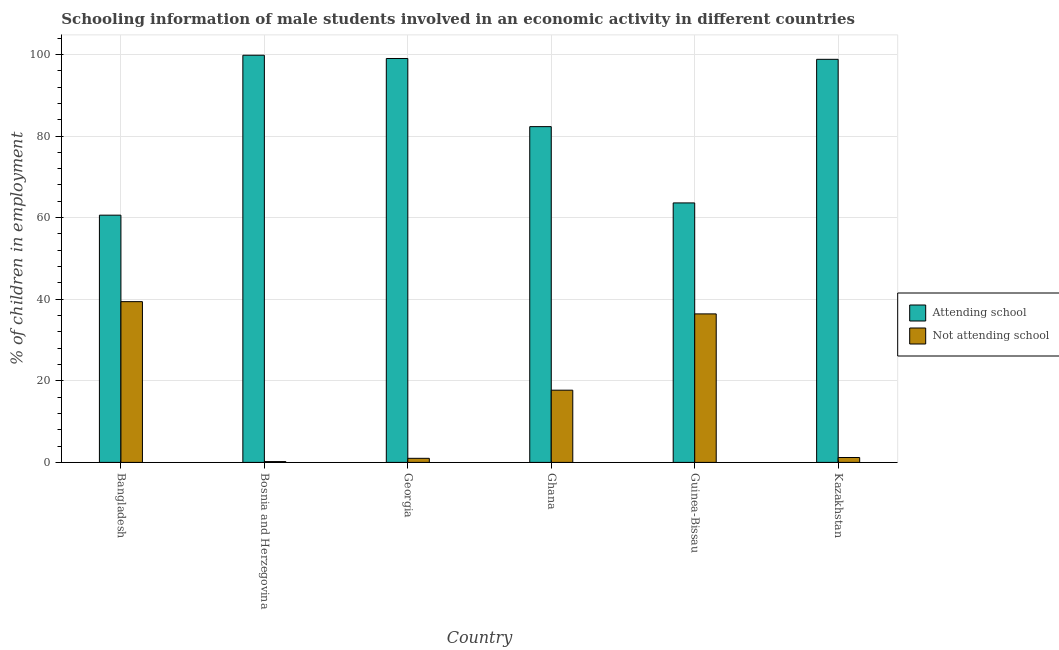Are the number of bars per tick equal to the number of legend labels?
Provide a short and direct response. Yes. How many bars are there on the 5th tick from the right?
Make the answer very short. 2. What is the label of the 3rd group of bars from the left?
Your response must be concise. Georgia. In how many cases, is the number of bars for a given country not equal to the number of legend labels?
Your response must be concise. 0. What is the percentage of employed males who are not attending school in Bosnia and Herzegovina?
Provide a short and direct response. 0.2. Across all countries, what is the maximum percentage of employed males who are not attending school?
Your answer should be very brief. 39.4. In which country was the percentage of employed males who are not attending school maximum?
Your answer should be very brief. Bangladesh. In which country was the percentage of employed males who are not attending school minimum?
Provide a short and direct response. Bosnia and Herzegovina. What is the total percentage of employed males who are not attending school in the graph?
Offer a very short reply. 95.9. What is the difference between the percentage of employed males who are not attending school in Ghana and that in Kazakhstan?
Make the answer very short. 16.5. What is the difference between the percentage of employed males who are not attending school in Georgia and the percentage of employed males who are attending school in Bosnia and Herzegovina?
Your answer should be compact. -98.8. What is the average percentage of employed males who are attending school per country?
Offer a very short reply. 84.02. What is the difference between the percentage of employed males who are not attending school and percentage of employed males who are attending school in Bosnia and Herzegovina?
Your answer should be very brief. -99.6. In how many countries, is the percentage of employed males who are not attending school greater than 84 %?
Provide a short and direct response. 0. What is the ratio of the percentage of employed males who are attending school in Georgia to that in Ghana?
Your response must be concise. 1.2. What is the difference between the highest and the lowest percentage of employed males who are attending school?
Make the answer very short. 39.2. In how many countries, is the percentage of employed males who are not attending school greater than the average percentage of employed males who are not attending school taken over all countries?
Keep it short and to the point. 3. Is the sum of the percentage of employed males who are attending school in Guinea-Bissau and Kazakhstan greater than the maximum percentage of employed males who are not attending school across all countries?
Your response must be concise. Yes. What does the 1st bar from the left in Bangladesh represents?
Your answer should be very brief. Attending school. What does the 1st bar from the right in Guinea-Bissau represents?
Offer a very short reply. Not attending school. How many bars are there?
Your response must be concise. 12. Does the graph contain grids?
Provide a short and direct response. Yes. How many legend labels are there?
Your answer should be very brief. 2. How are the legend labels stacked?
Your answer should be compact. Vertical. What is the title of the graph?
Make the answer very short. Schooling information of male students involved in an economic activity in different countries. What is the label or title of the Y-axis?
Offer a very short reply. % of children in employment. What is the % of children in employment of Attending school in Bangladesh?
Your response must be concise. 60.6. What is the % of children in employment in Not attending school in Bangladesh?
Your response must be concise. 39.4. What is the % of children in employment in Attending school in Bosnia and Herzegovina?
Your answer should be compact. 99.8. What is the % of children in employment in Not attending school in Georgia?
Offer a terse response. 1. What is the % of children in employment in Attending school in Ghana?
Provide a short and direct response. 82.3. What is the % of children in employment in Not attending school in Ghana?
Your response must be concise. 17.7. What is the % of children in employment of Attending school in Guinea-Bissau?
Make the answer very short. 63.6. What is the % of children in employment of Not attending school in Guinea-Bissau?
Your response must be concise. 36.4. What is the % of children in employment of Attending school in Kazakhstan?
Offer a very short reply. 98.8. Across all countries, what is the maximum % of children in employment of Attending school?
Make the answer very short. 99.8. Across all countries, what is the maximum % of children in employment of Not attending school?
Your answer should be compact. 39.4. Across all countries, what is the minimum % of children in employment in Attending school?
Your answer should be very brief. 60.6. What is the total % of children in employment of Attending school in the graph?
Ensure brevity in your answer.  504.1. What is the total % of children in employment of Not attending school in the graph?
Make the answer very short. 95.9. What is the difference between the % of children in employment in Attending school in Bangladesh and that in Bosnia and Herzegovina?
Your answer should be compact. -39.2. What is the difference between the % of children in employment of Not attending school in Bangladesh and that in Bosnia and Herzegovina?
Make the answer very short. 39.2. What is the difference between the % of children in employment in Attending school in Bangladesh and that in Georgia?
Make the answer very short. -38.4. What is the difference between the % of children in employment of Not attending school in Bangladesh and that in Georgia?
Ensure brevity in your answer.  38.4. What is the difference between the % of children in employment in Attending school in Bangladesh and that in Ghana?
Provide a succinct answer. -21.7. What is the difference between the % of children in employment in Not attending school in Bangladesh and that in Ghana?
Provide a succinct answer. 21.7. What is the difference between the % of children in employment in Not attending school in Bangladesh and that in Guinea-Bissau?
Provide a short and direct response. 3. What is the difference between the % of children in employment in Attending school in Bangladesh and that in Kazakhstan?
Offer a terse response. -38.2. What is the difference between the % of children in employment in Not attending school in Bangladesh and that in Kazakhstan?
Give a very brief answer. 38.2. What is the difference between the % of children in employment in Attending school in Bosnia and Herzegovina and that in Georgia?
Your answer should be very brief. 0.8. What is the difference between the % of children in employment in Not attending school in Bosnia and Herzegovina and that in Georgia?
Your answer should be very brief. -0.8. What is the difference between the % of children in employment in Not attending school in Bosnia and Herzegovina and that in Ghana?
Offer a terse response. -17.5. What is the difference between the % of children in employment in Attending school in Bosnia and Herzegovina and that in Guinea-Bissau?
Ensure brevity in your answer.  36.2. What is the difference between the % of children in employment in Not attending school in Bosnia and Herzegovina and that in Guinea-Bissau?
Your answer should be very brief. -36.2. What is the difference between the % of children in employment in Not attending school in Bosnia and Herzegovina and that in Kazakhstan?
Your response must be concise. -1. What is the difference between the % of children in employment in Attending school in Georgia and that in Ghana?
Your answer should be very brief. 16.7. What is the difference between the % of children in employment in Not attending school in Georgia and that in Ghana?
Offer a terse response. -16.7. What is the difference between the % of children in employment of Attending school in Georgia and that in Guinea-Bissau?
Offer a terse response. 35.4. What is the difference between the % of children in employment in Not attending school in Georgia and that in Guinea-Bissau?
Offer a terse response. -35.4. What is the difference between the % of children in employment of Not attending school in Georgia and that in Kazakhstan?
Your answer should be compact. -0.2. What is the difference between the % of children in employment in Not attending school in Ghana and that in Guinea-Bissau?
Your answer should be very brief. -18.7. What is the difference between the % of children in employment in Attending school in Ghana and that in Kazakhstan?
Provide a short and direct response. -16.5. What is the difference between the % of children in employment in Attending school in Guinea-Bissau and that in Kazakhstan?
Keep it short and to the point. -35.2. What is the difference between the % of children in employment in Not attending school in Guinea-Bissau and that in Kazakhstan?
Your answer should be compact. 35.2. What is the difference between the % of children in employment in Attending school in Bangladesh and the % of children in employment in Not attending school in Bosnia and Herzegovina?
Ensure brevity in your answer.  60.4. What is the difference between the % of children in employment in Attending school in Bangladesh and the % of children in employment in Not attending school in Georgia?
Your response must be concise. 59.6. What is the difference between the % of children in employment in Attending school in Bangladesh and the % of children in employment in Not attending school in Ghana?
Give a very brief answer. 42.9. What is the difference between the % of children in employment in Attending school in Bangladesh and the % of children in employment in Not attending school in Guinea-Bissau?
Your answer should be very brief. 24.2. What is the difference between the % of children in employment of Attending school in Bangladesh and the % of children in employment of Not attending school in Kazakhstan?
Offer a terse response. 59.4. What is the difference between the % of children in employment in Attending school in Bosnia and Herzegovina and the % of children in employment in Not attending school in Georgia?
Offer a terse response. 98.8. What is the difference between the % of children in employment in Attending school in Bosnia and Herzegovina and the % of children in employment in Not attending school in Ghana?
Ensure brevity in your answer.  82.1. What is the difference between the % of children in employment of Attending school in Bosnia and Herzegovina and the % of children in employment of Not attending school in Guinea-Bissau?
Your response must be concise. 63.4. What is the difference between the % of children in employment in Attending school in Bosnia and Herzegovina and the % of children in employment in Not attending school in Kazakhstan?
Offer a very short reply. 98.6. What is the difference between the % of children in employment in Attending school in Georgia and the % of children in employment in Not attending school in Ghana?
Offer a terse response. 81.3. What is the difference between the % of children in employment of Attending school in Georgia and the % of children in employment of Not attending school in Guinea-Bissau?
Make the answer very short. 62.6. What is the difference between the % of children in employment of Attending school in Georgia and the % of children in employment of Not attending school in Kazakhstan?
Provide a succinct answer. 97.8. What is the difference between the % of children in employment of Attending school in Ghana and the % of children in employment of Not attending school in Guinea-Bissau?
Give a very brief answer. 45.9. What is the difference between the % of children in employment in Attending school in Ghana and the % of children in employment in Not attending school in Kazakhstan?
Offer a terse response. 81.1. What is the difference between the % of children in employment in Attending school in Guinea-Bissau and the % of children in employment in Not attending school in Kazakhstan?
Your response must be concise. 62.4. What is the average % of children in employment of Attending school per country?
Offer a terse response. 84.02. What is the average % of children in employment in Not attending school per country?
Give a very brief answer. 15.98. What is the difference between the % of children in employment in Attending school and % of children in employment in Not attending school in Bangladesh?
Your answer should be compact. 21.2. What is the difference between the % of children in employment in Attending school and % of children in employment in Not attending school in Bosnia and Herzegovina?
Provide a short and direct response. 99.6. What is the difference between the % of children in employment in Attending school and % of children in employment in Not attending school in Ghana?
Your response must be concise. 64.6. What is the difference between the % of children in employment in Attending school and % of children in employment in Not attending school in Guinea-Bissau?
Provide a succinct answer. 27.2. What is the difference between the % of children in employment in Attending school and % of children in employment in Not attending school in Kazakhstan?
Offer a terse response. 97.6. What is the ratio of the % of children in employment in Attending school in Bangladesh to that in Bosnia and Herzegovina?
Provide a succinct answer. 0.61. What is the ratio of the % of children in employment of Not attending school in Bangladesh to that in Bosnia and Herzegovina?
Keep it short and to the point. 197. What is the ratio of the % of children in employment in Attending school in Bangladesh to that in Georgia?
Make the answer very short. 0.61. What is the ratio of the % of children in employment in Not attending school in Bangladesh to that in Georgia?
Your response must be concise. 39.4. What is the ratio of the % of children in employment of Attending school in Bangladesh to that in Ghana?
Give a very brief answer. 0.74. What is the ratio of the % of children in employment in Not attending school in Bangladesh to that in Ghana?
Your response must be concise. 2.23. What is the ratio of the % of children in employment in Attending school in Bangladesh to that in Guinea-Bissau?
Offer a terse response. 0.95. What is the ratio of the % of children in employment of Not attending school in Bangladesh to that in Guinea-Bissau?
Keep it short and to the point. 1.08. What is the ratio of the % of children in employment of Attending school in Bangladesh to that in Kazakhstan?
Give a very brief answer. 0.61. What is the ratio of the % of children in employment in Not attending school in Bangladesh to that in Kazakhstan?
Ensure brevity in your answer.  32.83. What is the ratio of the % of children in employment in Not attending school in Bosnia and Herzegovina to that in Georgia?
Provide a short and direct response. 0.2. What is the ratio of the % of children in employment in Attending school in Bosnia and Herzegovina to that in Ghana?
Offer a very short reply. 1.21. What is the ratio of the % of children in employment of Not attending school in Bosnia and Herzegovina to that in Ghana?
Provide a succinct answer. 0.01. What is the ratio of the % of children in employment of Attending school in Bosnia and Herzegovina to that in Guinea-Bissau?
Offer a terse response. 1.57. What is the ratio of the % of children in employment in Not attending school in Bosnia and Herzegovina to that in Guinea-Bissau?
Make the answer very short. 0.01. What is the ratio of the % of children in employment of Not attending school in Bosnia and Herzegovina to that in Kazakhstan?
Keep it short and to the point. 0.17. What is the ratio of the % of children in employment of Attending school in Georgia to that in Ghana?
Give a very brief answer. 1.2. What is the ratio of the % of children in employment in Not attending school in Georgia to that in Ghana?
Keep it short and to the point. 0.06. What is the ratio of the % of children in employment in Attending school in Georgia to that in Guinea-Bissau?
Give a very brief answer. 1.56. What is the ratio of the % of children in employment in Not attending school in Georgia to that in Guinea-Bissau?
Provide a succinct answer. 0.03. What is the ratio of the % of children in employment of Attending school in Ghana to that in Guinea-Bissau?
Offer a very short reply. 1.29. What is the ratio of the % of children in employment in Not attending school in Ghana to that in Guinea-Bissau?
Your answer should be very brief. 0.49. What is the ratio of the % of children in employment in Attending school in Ghana to that in Kazakhstan?
Your response must be concise. 0.83. What is the ratio of the % of children in employment of Not attending school in Ghana to that in Kazakhstan?
Your answer should be very brief. 14.75. What is the ratio of the % of children in employment of Attending school in Guinea-Bissau to that in Kazakhstan?
Your answer should be very brief. 0.64. What is the ratio of the % of children in employment in Not attending school in Guinea-Bissau to that in Kazakhstan?
Provide a short and direct response. 30.33. What is the difference between the highest and the second highest % of children in employment in Attending school?
Offer a terse response. 0.8. What is the difference between the highest and the second highest % of children in employment of Not attending school?
Keep it short and to the point. 3. What is the difference between the highest and the lowest % of children in employment of Attending school?
Make the answer very short. 39.2. What is the difference between the highest and the lowest % of children in employment in Not attending school?
Make the answer very short. 39.2. 